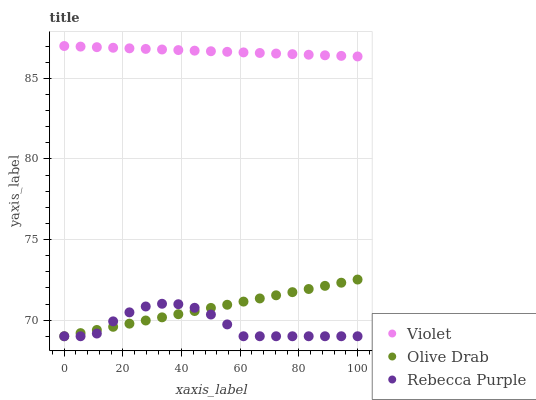Does Rebecca Purple have the minimum area under the curve?
Answer yes or no. Yes. Does Violet have the maximum area under the curve?
Answer yes or no. Yes. Does Olive Drab have the minimum area under the curve?
Answer yes or no. No. Does Olive Drab have the maximum area under the curve?
Answer yes or no. No. Is Olive Drab the smoothest?
Answer yes or no. Yes. Is Rebecca Purple the roughest?
Answer yes or no. Yes. Is Violet the smoothest?
Answer yes or no. No. Is Violet the roughest?
Answer yes or no. No. Does Rebecca Purple have the lowest value?
Answer yes or no. Yes. Does Violet have the lowest value?
Answer yes or no. No. Does Violet have the highest value?
Answer yes or no. Yes. Does Olive Drab have the highest value?
Answer yes or no. No. Is Olive Drab less than Violet?
Answer yes or no. Yes. Is Violet greater than Olive Drab?
Answer yes or no. Yes. Does Rebecca Purple intersect Olive Drab?
Answer yes or no. Yes. Is Rebecca Purple less than Olive Drab?
Answer yes or no. No. Is Rebecca Purple greater than Olive Drab?
Answer yes or no. No. Does Olive Drab intersect Violet?
Answer yes or no. No. 